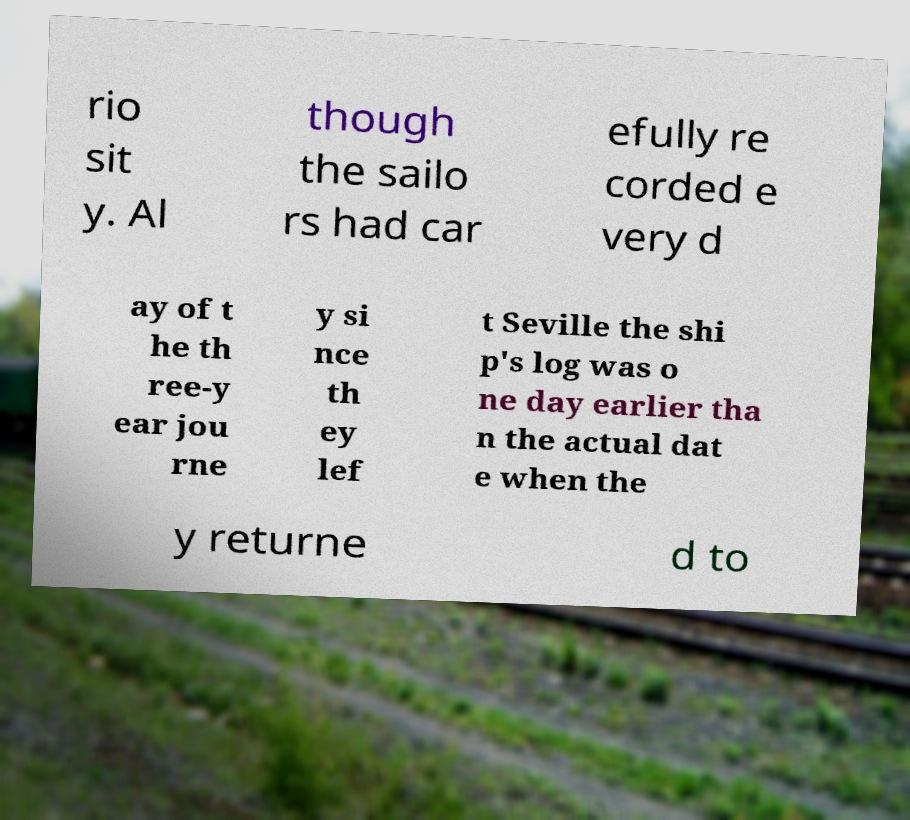Can you accurately transcribe the text from the provided image for me? rio sit y. Al though the sailo rs had car efully re corded e very d ay of t he th ree-y ear jou rne y si nce th ey lef t Seville the shi p's log was o ne day earlier tha n the actual dat e when the y returne d to 